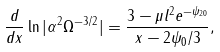<formula> <loc_0><loc_0><loc_500><loc_500>\frac { d } { d x } \ln | \alpha ^ { 2 } \Omega ^ { - 3 / 2 } | = \frac { 3 - \mu l ^ { 2 } e ^ { - \psi _ { 2 0 } } } { x - 2 \psi _ { 0 } / 3 } ,</formula> 